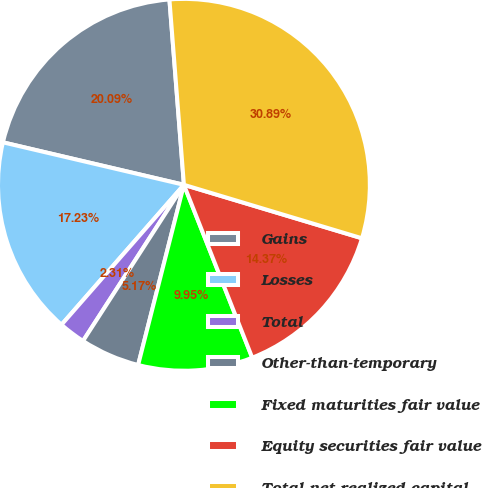Convert chart. <chart><loc_0><loc_0><loc_500><loc_500><pie_chart><fcel>Gains<fcel>Losses<fcel>Total<fcel>Other-than-temporary<fcel>Fixed maturities fair value<fcel>Equity securities fair value<fcel>Total net realized capital<nl><fcel>20.09%<fcel>17.23%<fcel>2.31%<fcel>5.17%<fcel>9.95%<fcel>14.37%<fcel>30.89%<nl></chart> 